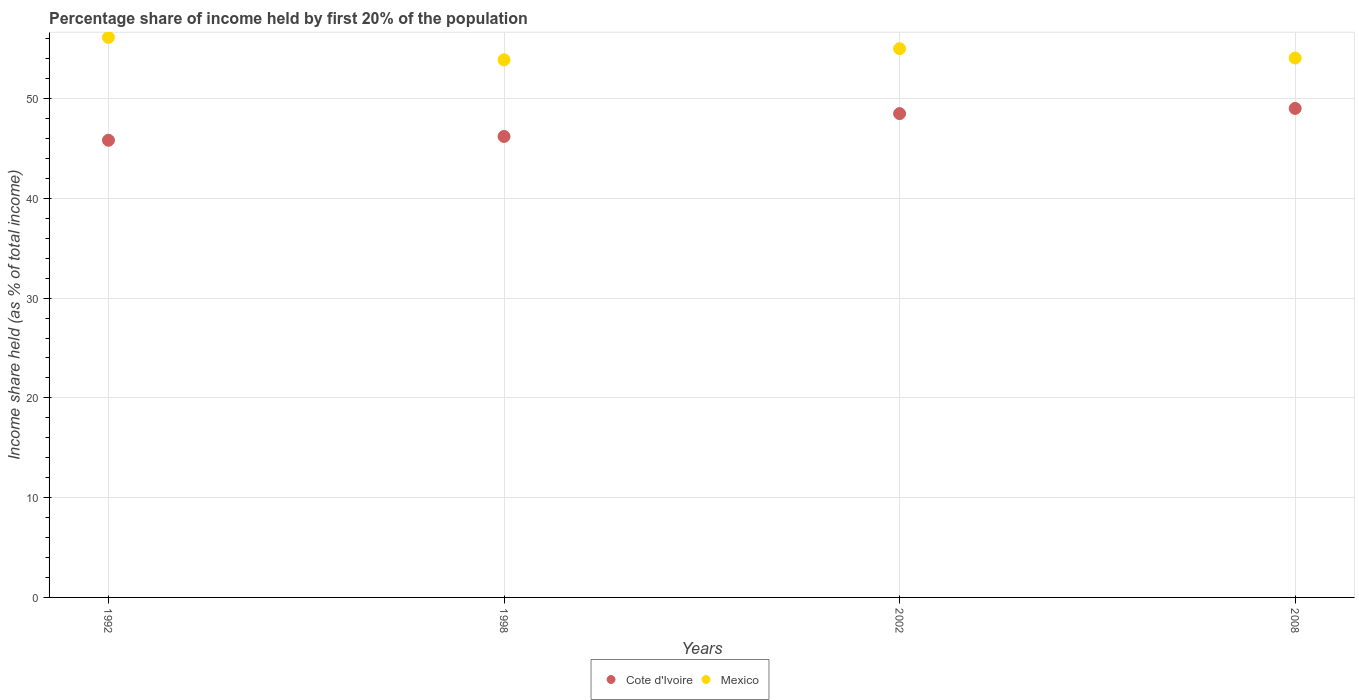How many different coloured dotlines are there?
Your response must be concise. 2. What is the share of income held by first 20% of the population in Cote d'Ivoire in 2008?
Provide a succinct answer. 49.01. Across all years, what is the maximum share of income held by first 20% of the population in Mexico?
Provide a succinct answer. 56.13. Across all years, what is the minimum share of income held by first 20% of the population in Mexico?
Provide a short and direct response. 53.88. What is the total share of income held by first 20% of the population in Cote d'Ivoire in the graph?
Give a very brief answer. 189.52. What is the difference between the share of income held by first 20% of the population in Cote d'Ivoire in 1992 and that in 2002?
Provide a short and direct response. -2.67. What is the difference between the share of income held by first 20% of the population in Mexico in 1998 and the share of income held by first 20% of the population in Cote d'Ivoire in 1992?
Provide a short and direct response. 8.06. What is the average share of income held by first 20% of the population in Cote d'Ivoire per year?
Your answer should be very brief. 47.38. In the year 2008, what is the difference between the share of income held by first 20% of the population in Mexico and share of income held by first 20% of the population in Cote d'Ivoire?
Keep it short and to the point. 5.05. What is the ratio of the share of income held by first 20% of the population in Cote d'Ivoire in 1992 to that in 2002?
Your answer should be compact. 0.94. What is the difference between the highest and the second highest share of income held by first 20% of the population in Mexico?
Make the answer very short. 1.13. What is the difference between the highest and the lowest share of income held by first 20% of the population in Mexico?
Offer a very short reply. 2.25. Is the sum of the share of income held by first 20% of the population in Cote d'Ivoire in 1998 and 2002 greater than the maximum share of income held by first 20% of the population in Mexico across all years?
Offer a very short reply. Yes. What is the difference between two consecutive major ticks on the Y-axis?
Your answer should be compact. 10. Are the values on the major ticks of Y-axis written in scientific E-notation?
Offer a very short reply. No. Where does the legend appear in the graph?
Ensure brevity in your answer.  Bottom center. How many legend labels are there?
Make the answer very short. 2. How are the legend labels stacked?
Provide a succinct answer. Horizontal. What is the title of the graph?
Give a very brief answer. Percentage share of income held by first 20% of the population. Does "Euro area" appear as one of the legend labels in the graph?
Provide a succinct answer. No. What is the label or title of the Y-axis?
Your response must be concise. Income share held (as % of total income). What is the Income share held (as % of total income) of Cote d'Ivoire in 1992?
Offer a terse response. 45.82. What is the Income share held (as % of total income) in Mexico in 1992?
Provide a succinct answer. 56.13. What is the Income share held (as % of total income) of Cote d'Ivoire in 1998?
Offer a very short reply. 46.2. What is the Income share held (as % of total income) in Mexico in 1998?
Provide a short and direct response. 53.88. What is the Income share held (as % of total income) of Cote d'Ivoire in 2002?
Your answer should be compact. 48.49. What is the Income share held (as % of total income) in Cote d'Ivoire in 2008?
Provide a short and direct response. 49.01. What is the Income share held (as % of total income) in Mexico in 2008?
Your response must be concise. 54.06. Across all years, what is the maximum Income share held (as % of total income) in Cote d'Ivoire?
Ensure brevity in your answer.  49.01. Across all years, what is the maximum Income share held (as % of total income) in Mexico?
Ensure brevity in your answer.  56.13. Across all years, what is the minimum Income share held (as % of total income) in Cote d'Ivoire?
Give a very brief answer. 45.82. Across all years, what is the minimum Income share held (as % of total income) in Mexico?
Provide a short and direct response. 53.88. What is the total Income share held (as % of total income) of Cote d'Ivoire in the graph?
Offer a terse response. 189.52. What is the total Income share held (as % of total income) in Mexico in the graph?
Your answer should be very brief. 219.07. What is the difference between the Income share held (as % of total income) of Cote d'Ivoire in 1992 and that in 1998?
Your response must be concise. -0.38. What is the difference between the Income share held (as % of total income) in Mexico in 1992 and that in 1998?
Make the answer very short. 2.25. What is the difference between the Income share held (as % of total income) in Cote d'Ivoire in 1992 and that in 2002?
Your answer should be very brief. -2.67. What is the difference between the Income share held (as % of total income) in Mexico in 1992 and that in 2002?
Give a very brief answer. 1.13. What is the difference between the Income share held (as % of total income) in Cote d'Ivoire in 1992 and that in 2008?
Offer a very short reply. -3.19. What is the difference between the Income share held (as % of total income) of Mexico in 1992 and that in 2008?
Provide a succinct answer. 2.07. What is the difference between the Income share held (as % of total income) of Cote d'Ivoire in 1998 and that in 2002?
Offer a very short reply. -2.29. What is the difference between the Income share held (as % of total income) in Mexico in 1998 and that in 2002?
Offer a terse response. -1.12. What is the difference between the Income share held (as % of total income) of Cote d'Ivoire in 1998 and that in 2008?
Your answer should be compact. -2.81. What is the difference between the Income share held (as % of total income) of Mexico in 1998 and that in 2008?
Offer a very short reply. -0.18. What is the difference between the Income share held (as % of total income) in Cote d'Ivoire in 2002 and that in 2008?
Give a very brief answer. -0.52. What is the difference between the Income share held (as % of total income) of Cote d'Ivoire in 1992 and the Income share held (as % of total income) of Mexico in 1998?
Give a very brief answer. -8.06. What is the difference between the Income share held (as % of total income) of Cote d'Ivoire in 1992 and the Income share held (as % of total income) of Mexico in 2002?
Provide a succinct answer. -9.18. What is the difference between the Income share held (as % of total income) in Cote d'Ivoire in 1992 and the Income share held (as % of total income) in Mexico in 2008?
Provide a short and direct response. -8.24. What is the difference between the Income share held (as % of total income) in Cote d'Ivoire in 1998 and the Income share held (as % of total income) in Mexico in 2008?
Your answer should be compact. -7.86. What is the difference between the Income share held (as % of total income) in Cote d'Ivoire in 2002 and the Income share held (as % of total income) in Mexico in 2008?
Offer a terse response. -5.57. What is the average Income share held (as % of total income) in Cote d'Ivoire per year?
Keep it short and to the point. 47.38. What is the average Income share held (as % of total income) of Mexico per year?
Offer a terse response. 54.77. In the year 1992, what is the difference between the Income share held (as % of total income) of Cote d'Ivoire and Income share held (as % of total income) of Mexico?
Offer a terse response. -10.31. In the year 1998, what is the difference between the Income share held (as % of total income) of Cote d'Ivoire and Income share held (as % of total income) of Mexico?
Your answer should be very brief. -7.68. In the year 2002, what is the difference between the Income share held (as % of total income) of Cote d'Ivoire and Income share held (as % of total income) of Mexico?
Ensure brevity in your answer.  -6.51. In the year 2008, what is the difference between the Income share held (as % of total income) in Cote d'Ivoire and Income share held (as % of total income) in Mexico?
Make the answer very short. -5.05. What is the ratio of the Income share held (as % of total income) in Mexico in 1992 to that in 1998?
Your response must be concise. 1.04. What is the ratio of the Income share held (as % of total income) in Cote d'Ivoire in 1992 to that in 2002?
Keep it short and to the point. 0.94. What is the ratio of the Income share held (as % of total income) in Mexico in 1992 to that in 2002?
Give a very brief answer. 1.02. What is the ratio of the Income share held (as % of total income) in Cote d'Ivoire in 1992 to that in 2008?
Give a very brief answer. 0.93. What is the ratio of the Income share held (as % of total income) of Mexico in 1992 to that in 2008?
Your answer should be compact. 1.04. What is the ratio of the Income share held (as % of total income) of Cote d'Ivoire in 1998 to that in 2002?
Offer a very short reply. 0.95. What is the ratio of the Income share held (as % of total income) of Mexico in 1998 to that in 2002?
Your answer should be very brief. 0.98. What is the ratio of the Income share held (as % of total income) of Cote d'Ivoire in 1998 to that in 2008?
Keep it short and to the point. 0.94. What is the ratio of the Income share held (as % of total income) of Mexico in 2002 to that in 2008?
Make the answer very short. 1.02. What is the difference between the highest and the second highest Income share held (as % of total income) in Cote d'Ivoire?
Make the answer very short. 0.52. What is the difference between the highest and the second highest Income share held (as % of total income) in Mexico?
Offer a terse response. 1.13. What is the difference between the highest and the lowest Income share held (as % of total income) in Cote d'Ivoire?
Make the answer very short. 3.19. What is the difference between the highest and the lowest Income share held (as % of total income) in Mexico?
Your answer should be very brief. 2.25. 